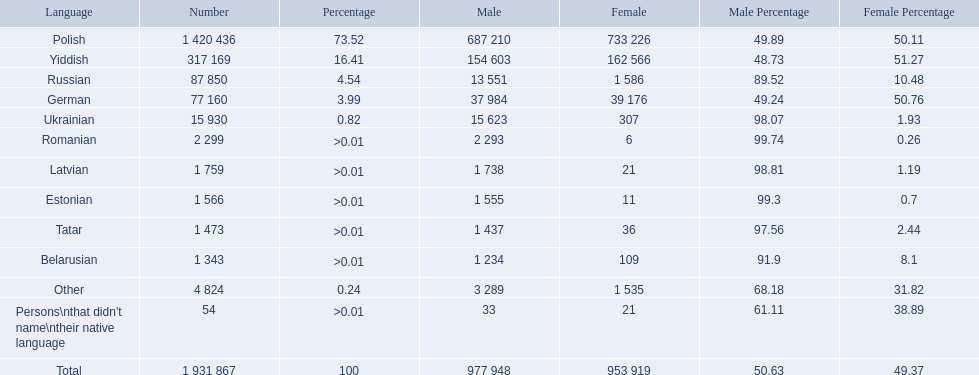What is the percentage of polish speakers? 73.52. What is the next highest percentage of speakers? 16.41. What language is this percentage? Yiddish. 